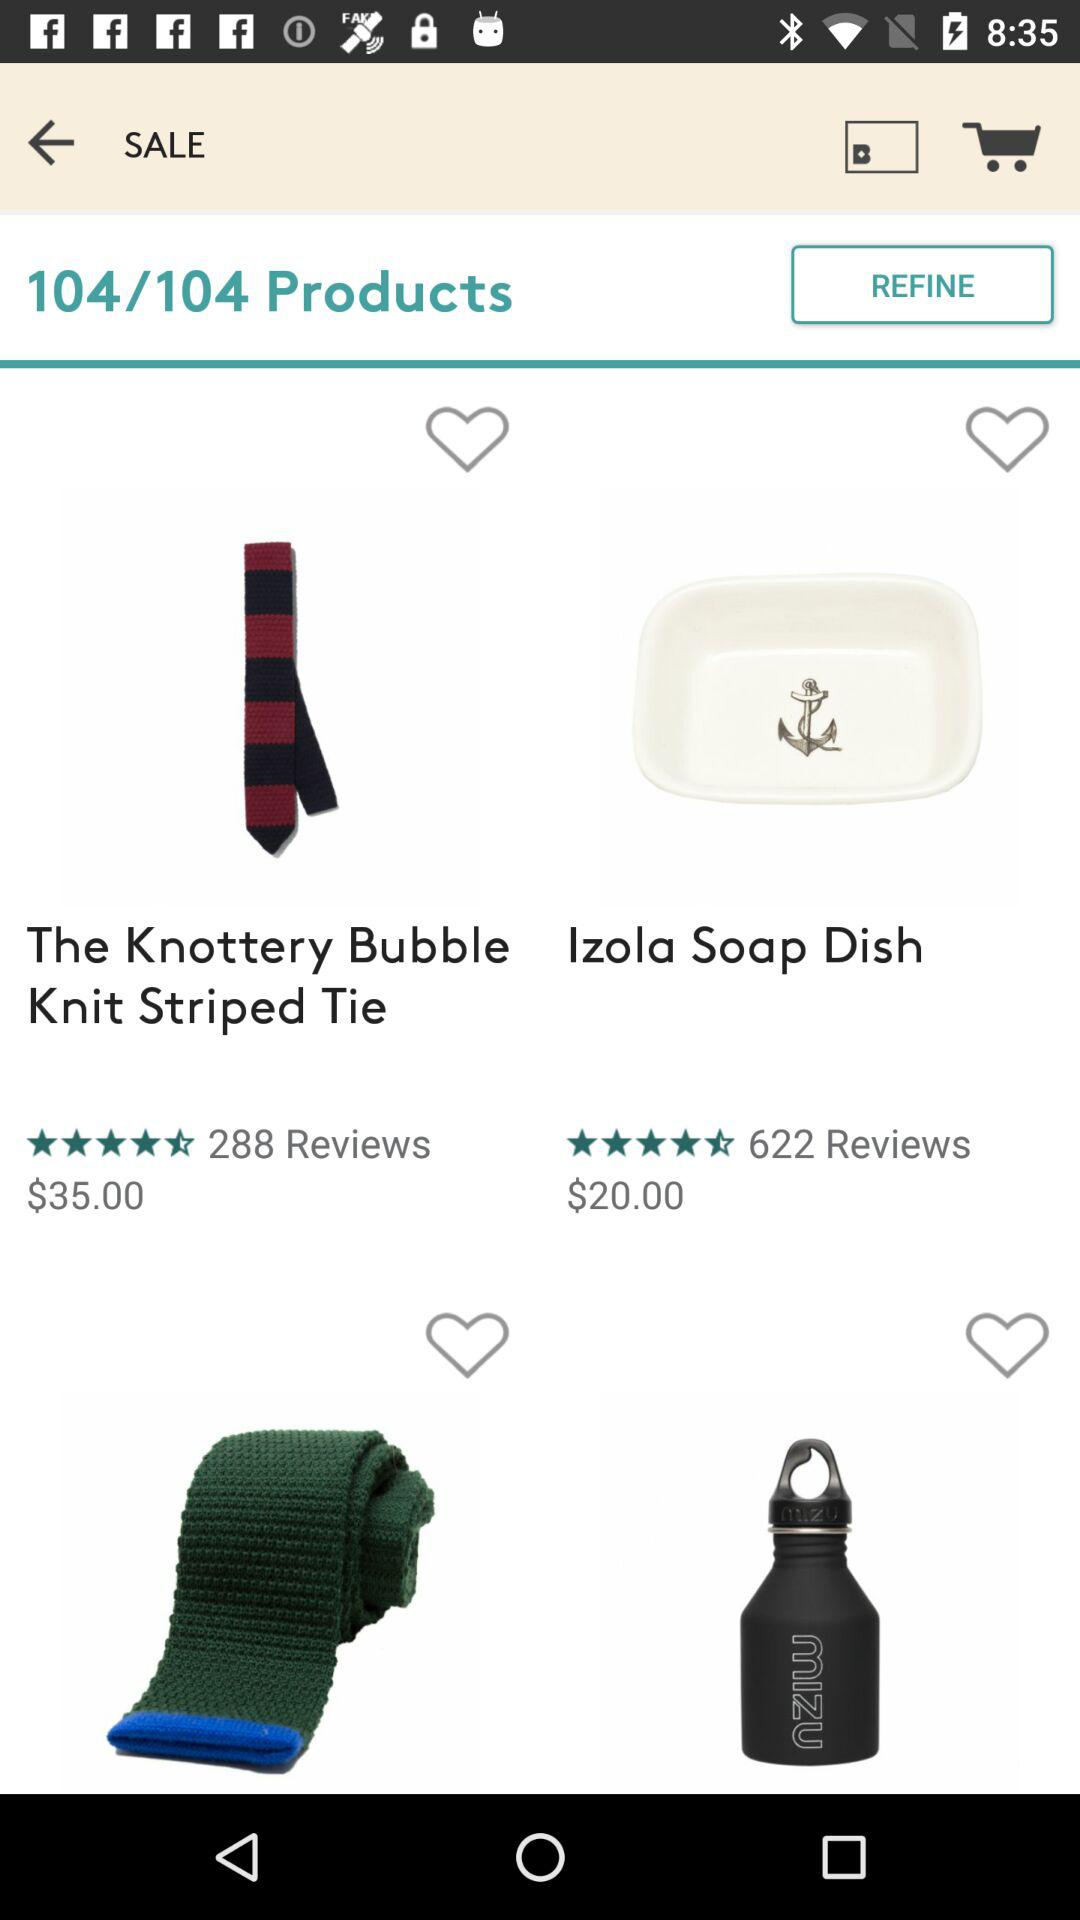What is the price of "Izola Soap Dish"? The price of "Izola Soap Dish" is $20.00. 